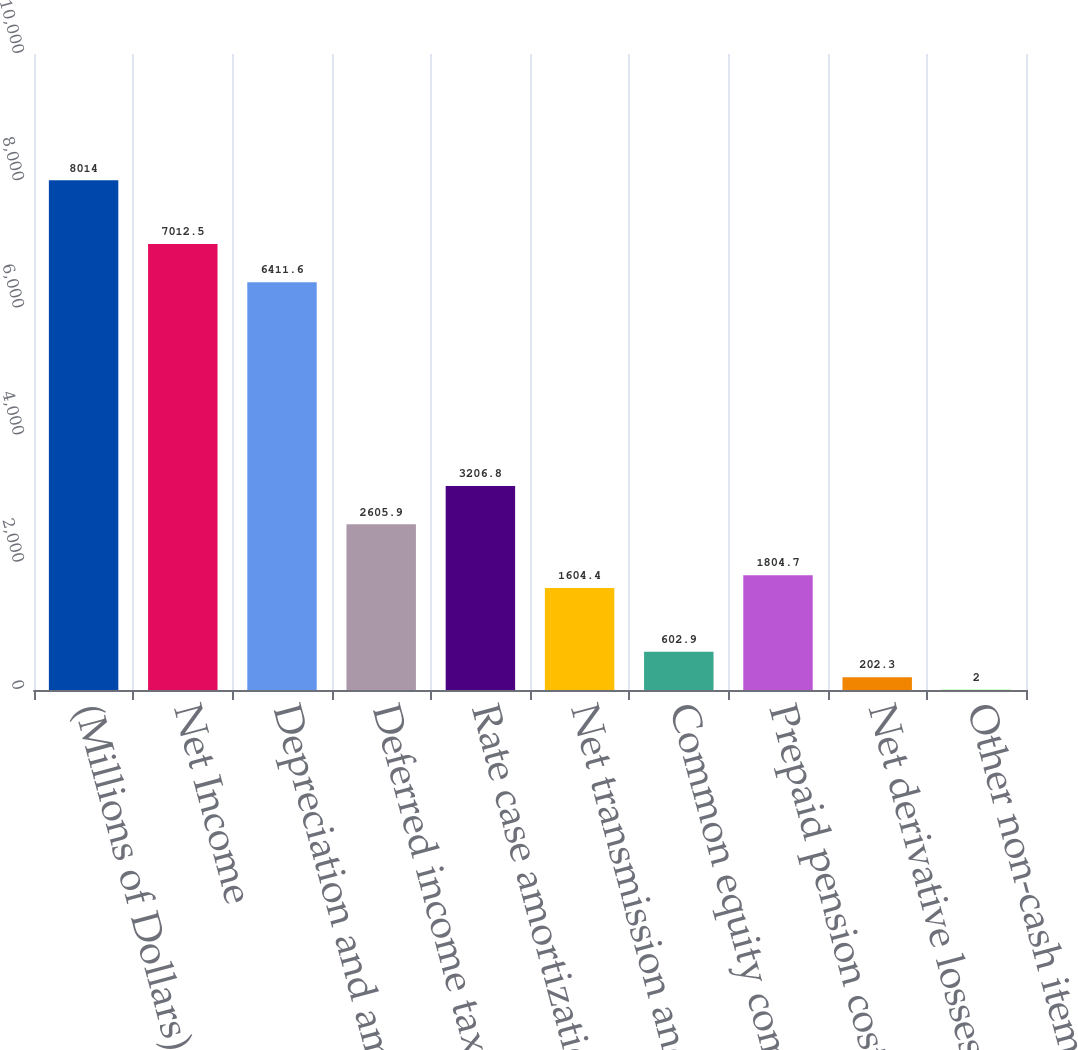Convert chart. <chart><loc_0><loc_0><loc_500><loc_500><bar_chart><fcel>(Millions of Dollars)<fcel>Net Income<fcel>Depreciation and amortization<fcel>Deferred income taxes<fcel>Rate case amortization and<fcel>Net transmission and<fcel>Common equity component of<fcel>Prepaid pension costs (net of<fcel>Net derivative losses<fcel>Other non-cash items (net)<nl><fcel>8014<fcel>7012.5<fcel>6411.6<fcel>2605.9<fcel>3206.8<fcel>1604.4<fcel>602.9<fcel>1804.7<fcel>202.3<fcel>2<nl></chart> 